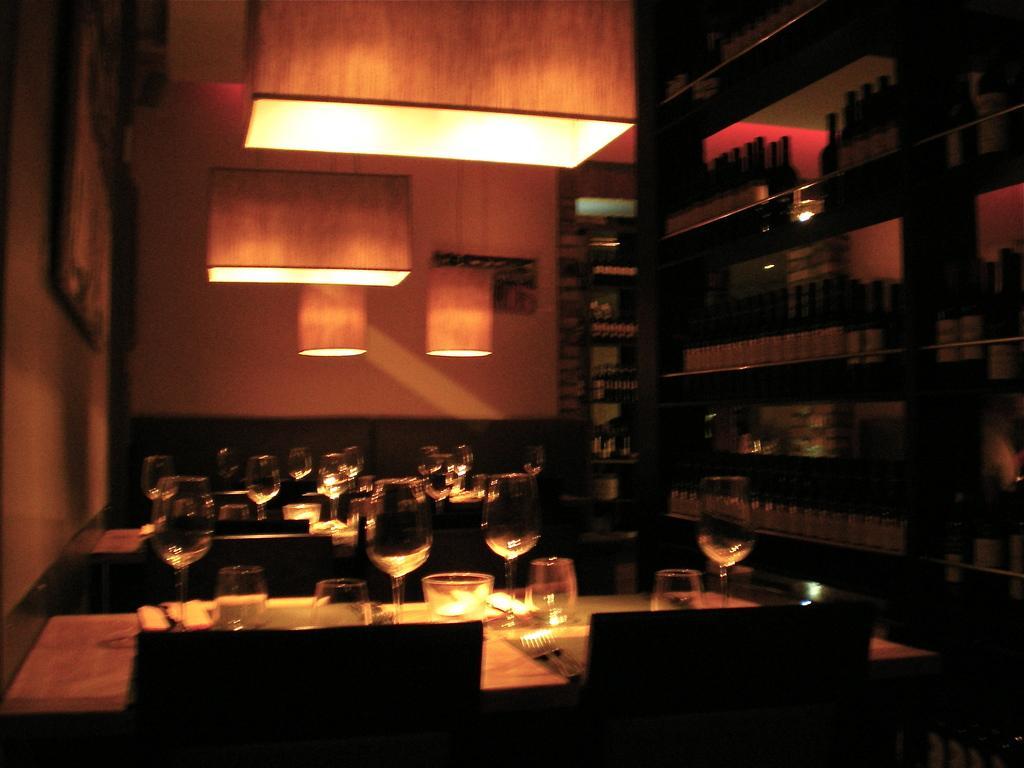Could you give a brief overview of what you see in this image? This image is clicked inside bar. There is a wine track here on the right side. There are lights on the top. And there are tables in the middle of the image. Glasses are placed on the table. There are also chairs near the tables. 